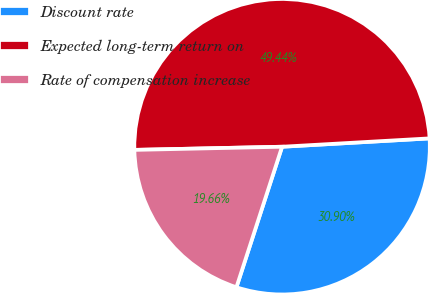Convert chart to OTSL. <chart><loc_0><loc_0><loc_500><loc_500><pie_chart><fcel>Discount rate<fcel>Expected long-term return on<fcel>Rate of compensation increase<nl><fcel>30.9%<fcel>49.44%<fcel>19.66%<nl></chart> 